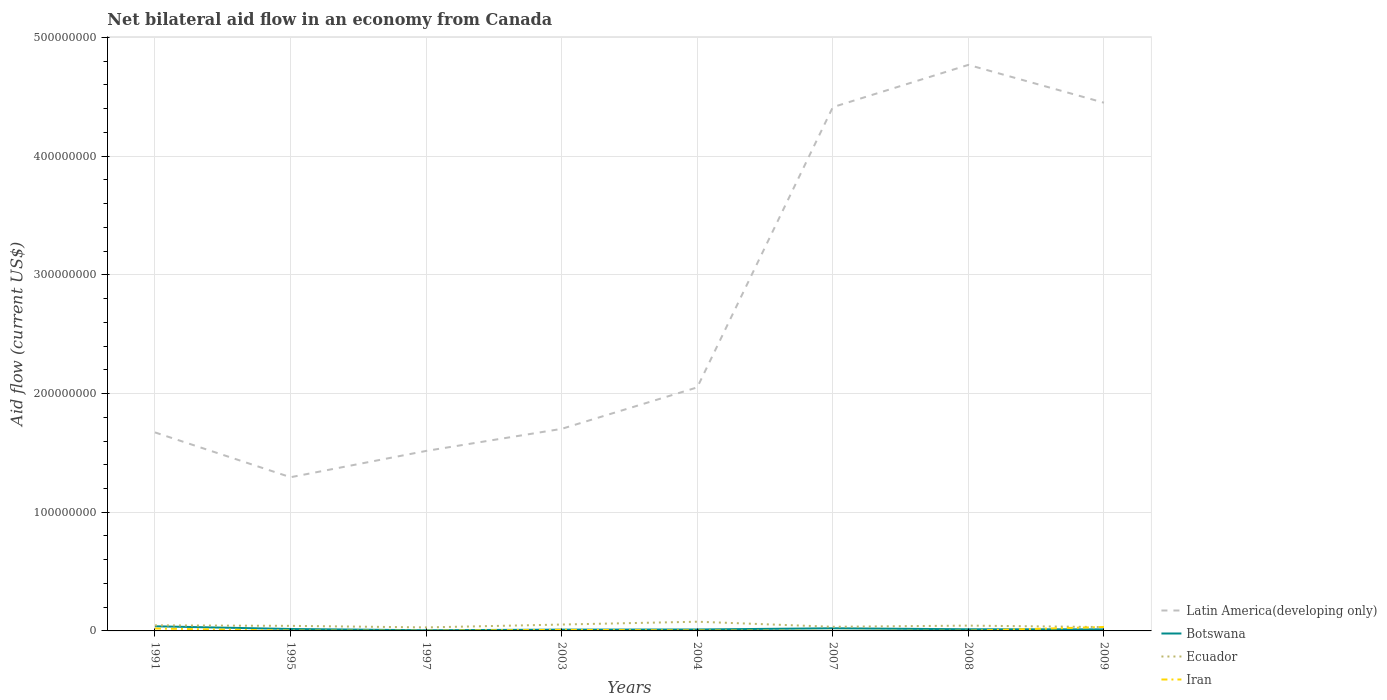Does the line corresponding to Ecuador intersect with the line corresponding to Iran?
Offer a terse response. Yes. Across all years, what is the maximum net bilateral aid flow in Botswana?
Provide a succinct answer. 5.70e+05. What is the total net bilateral aid flow in Botswana in the graph?
Give a very brief answer. 2.80e+06. What is the difference between the highest and the second highest net bilateral aid flow in Botswana?
Offer a very short reply. 3.32e+06. Is the net bilateral aid flow in Botswana strictly greater than the net bilateral aid flow in Latin America(developing only) over the years?
Your answer should be very brief. Yes. How many years are there in the graph?
Make the answer very short. 8. Are the values on the major ticks of Y-axis written in scientific E-notation?
Provide a succinct answer. No. Does the graph contain any zero values?
Offer a very short reply. No. What is the title of the graph?
Offer a very short reply. Net bilateral aid flow in an economy from Canada. What is the label or title of the X-axis?
Your answer should be compact. Years. What is the Aid flow (current US$) in Latin America(developing only) in 1991?
Give a very brief answer. 1.67e+08. What is the Aid flow (current US$) of Botswana in 1991?
Make the answer very short. 3.89e+06. What is the Aid flow (current US$) of Ecuador in 1991?
Your response must be concise. 4.69e+06. What is the Aid flow (current US$) in Iran in 1991?
Provide a succinct answer. 2.01e+06. What is the Aid flow (current US$) in Latin America(developing only) in 1995?
Provide a succinct answer. 1.29e+08. What is the Aid flow (current US$) in Botswana in 1995?
Your answer should be compact. 1.63e+06. What is the Aid flow (current US$) of Ecuador in 1995?
Offer a terse response. 4.27e+06. What is the Aid flow (current US$) of Latin America(developing only) in 1997?
Keep it short and to the point. 1.52e+08. What is the Aid flow (current US$) of Botswana in 1997?
Your response must be concise. 5.70e+05. What is the Aid flow (current US$) of Ecuador in 1997?
Give a very brief answer. 2.96e+06. What is the Aid flow (current US$) in Iran in 1997?
Your answer should be compact. 1.40e+05. What is the Aid flow (current US$) of Latin America(developing only) in 2003?
Offer a very short reply. 1.70e+08. What is the Aid flow (current US$) in Botswana in 2003?
Give a very brief answer. 1.09e+06. What is the Aid flow (current US$) of Ecuador in 2003?
Provide a succinct answer. 5.37e+06. What is the Aid flow (current US$) in Latin America(developing only) in 2004?
Your response must be concise. 2.05e+08. What is the Aid flow (current US$) in Botswana in 2004?
Offer a terse response. 1.21e+06. What is the Aid flow (current US$) of Ecuador in 2004?
Your answer should be compact. 7.76e+06. What is the Aid flow (current US$) of Iran in 2004?
Offer a very short reply. 4.30e+05. What is the Aid flow (current US$) of Latin America(developing only) in 2007?
Your response must be concise. 4.41e+08. What is the Aid flow (current US$) in Botswana in 2007?
Provide a short and direct response. 2.22e+06. What is the Aid flow (current US$) of Ecuador in 2007?
Make the answer very short. 3.49e+06. What is the Aid flow (current US$) of Iran in 2007?
Keep it short and to the point. 5.00e+04. What is the Aid flow (current US$) of Latin America(developing only) in 2008?
Offer a very short reply. 4.77e+08. What is the Aid flow (current US$) in Botswana in 2008?
Offer a terse response. 1.40e+06. What is the Aid flow (current US$) in Ecuador in 2008?
Give a very brief answer. 4.48e+06. What is the Aid flow (current US$) of Iran in 2008?
Offer a terse response. 1.90e+05. What is the Aid flow (current US$) of Latin America(developing only) in 2009?
Provide a short and direct response. 4.45e+08. What is the Aid flow (current US$) of Botswana in 2009?
Ensure brevity in your answer.  1.31e+06. What is the Aid flow (current US$) of Ecuador in 2009?
Give a very brief answer. 3.24e+06. What is the Aid flow (current US$) in Iran in 2009?
Keep it short and to the point. 3.31e+06. Across all years, what is the maximum Aid flow (current US$) in Latin America(developing only)?
Your response must be concise. 4.77e+08. Across all years, what is the maximum Aid flow (current US$) in Botswana?
Offer a terse response. 3.89e+06. Across all years, what is the maximum Aid flow (current US$) of Ecuador?
Your answer should be very brief. 7.76e+06. Across all years, what is the maximum Aid flow (current US$) of Iran?
Give a very brief answer. 3.31e+06. Across all years, what is the minimum Aid flow (current US$) of Latin America(developing only)?
Ensure brevity in your answer.  1.29e+08. Across all years, what is the minimum Aid flow (current US$) in Botswana?
Make the answer very short. 5.70e+05. Across all years, what is the minimum Aid flow (current US$) of Ecuador?
Offer a terse response. 2.96e+06. What is the total Aid flow (current US$) of Latin America(developing only) in the graph?
Your answer should be compact. 2.19e+09. What is the total Aid flow (current US$) of Botswana in the graph?
Provide a short and direct response. 1.33e+07. What is the total Aid flow (current US$) of Ecuador in the graph?
Ensure brevity in your answer.  3.63e+07. What is the total Aid flow (current US$) of Iran in the graph?
Make the answer very short. 7.32e+06. What is the difference between the Aid flow (current US$) in Latin America(developing only) in 1991 and that in 1995?
Provide a succinct answer. 3.78e+07. What is the difference between the Aid flow (current US$) in Botswana in 1991 and that in 1995?
Your answer should be compact. 2.26e+06. What is the difference between the Aid flow (current US$) in Ecuador in 1991 and that in 1995?
Keep it short and to the point. 4.20e+05. What is the difference between the Aid flow (current US$) of Iran in 1991 and that in 1995?
Ensure brevity in your answer.  1.72e+06. What is the difference between the Aid flow (current US$) in Latin America(developing only) in 1991 and that in 1997?
Make the answer very short. 1.56e+07. What is the difference between the Aid flow (current US$) in Botswana in 1991 and that in 1997?
Offer a very short reply. 3.32e+06. What is the difference between the Aid flow (current US$) in Ecuador in 1991 and that in 1997?
Make the answer very short. 1.73e+06. What is the difference between the Aid flow (current US$) of Iran in 1991 and that in 1997?
Your response must be concise. 1.87e+06. What is the difference between the Aid flow (current US$) in Latin America(developing only) in 1991 and that in 2003?
Offer a very short reply. -2.99e+06. What is the difference between the Aid flow (current US$) in Botswana in 1991 and that in 2003?
Your answer should be very brief. 2.80e+06. What is the difference between the Aid flow (current US$) of Ecuador in 1991 and that in 2003?
Offer a very short reply. -6.80e+05. What is the difference between the Aid flow (current US$) of Iran in 1991 and that in 2003?
Ensure brevity in your answer.  1.11e+06. What is the difference between the Aid flow (current US$) in Latin America(developing only) in 1991 and that in 2004?
Ensure brevity in your answer.  -3.79e+07. What is the difference between the Aid flow (current US$) of Botswana in 1991 and that in 2004?
Keep it short and to the point. 2.68e+06. What is the difference between the Aid flow (current US$) of Ecuador in 1991 and that in 2004?
Ensure brevity in your answer.  -3.07e+06. What is the difference between the Aid flow (current US$) of Iran in 1991 and that in 2004?
Provide a short and direct response. 1.58e+06. What is the difference between the Aid flow (current US$) of Latin America(developing only) in 1991 and that in 2007?
Give a very brief answer. -2.74e+08. What is the difference between the Aid flow (current US$) in Botswana in 1991 and that in 2007?
Provide a short and direct response. 1.67e+06. What is the difference between the Aid flow (current US$) of Ecuador in 1991 and that in 2007?
Give a very brief answer. 1.20e+06. What is the difference between the Aid flow (current US$) of Iran in 1991 and that in 2007?
Your answer should be very brief. 1.96e+06. What is the difference between the Aid flow (current US$) of Latin America(developing only) in 1991 and that in 2008?
Ensure brevity in your answer.  -3.10e+08. What is the difference between the Aid flow (current US$) of Botswana in 1991 and that in 2008?
Offer a terse response. 2.49e+06. What is the difference between the Aid flow (current US$) of Iran in 1991 and that in 2008?
Provide a succinct answer. 1.82e+06. What is the difference between the Aid flow (current US$) of Latin America(developing only) in 1991 and that in 2009?
Provide a short and direct response. -2.78e+08. What is the difference between the Aid flow (current US$) in Botswana in 1991 and that in 2009?
Keep it short and to the point. 2.58e+06. What is the difference between the Aid flow (current US$) of Ecuador in 1991 and that in 2009?
Provide a succinct answer. 1.45e+06. What is the difference between the Aid flow (current US$) of Iran in 1991 and that in 2009?
Your answer should be compact. -1.30e+06. What is the difference between the Aid flow (current US$) in Latin America(developing only) in 1995 and that in 1997?
Your answer should be compact. -2.22e+07. What is the difference between the Aid flow (current US$) in Botswana in 1995 and that in 1997?
Your answer should be compact. 1.06e+06. What is the difference between the Aid flow (current US$) of Ecuador in 1995 and that in 1997?
Provide a short and direct response. 1.31e+06. What is the difference between the Aid flow (current US$) in Iran in 1995 and that in 1997?
Provide a succinct answer. 1.50e+05. What is the difference between the Aid flow (current US$) of Latin America(developing only) in 1995 and that in 2003?
Your response must be concise. -4.08e+07. What is the difference between the Aid flow (current US$) in Botswana in 1995 and that in 2003?
Provide a short and direct response. 5.40e+05. What is the difference between the Aid flow (current US$) in Ecuador in 1995 and that in 2003?
Ensure brevity in your answer.  -1.10e+06. What is the difference between the Aid flow (current US$) in Iran in 1995 and that in 2003?
Make the answer very short. -6.10e+05. What is the difference between the Aid flow (current US$) of Latin America(developing only) in 1995 and that in 2004?
Give a very brief answer. -7.57e+07. What is the difference between the Aid flow (current US$) of Ecuador in 1995 and that in 2004?
Give a very brief answer. -3.49e+06. What is the difference between the Aid flow (current US$) of Latin America(developing only) in 1995 and that in 2007?
Your answer should be compact. -3.12e+08. What is the difference between the Aid flow (current US$) in Botswana in 1995 and that in 2007?
Provide a short and direct response. -5.90e+05. What is the difference between the Aid flow (current US$) in Ecuador in 1995 and that in 2007?
Your answer should be compact. 7.80e+05. What is the difference between the Aid flow (current US$) of Iran in 1995 and that in 2007?
Your answer should be very brief. 2.40e+05. What is the difference between the Aid flow (current US$) in Latin America(developing only) in 1995 and that in 2008?
Your answer should be compact. -3.47e+08. What is the difference between the Aid flow (current US$) in Botswana in 1995 and that in 2008?
Your answer should be compact. 2.30e+05. What is the difference between the Aid flow (current US$) in Ecuador in 1995 and that in 2008?
Keep it short and to the point. -2.10e+05. What is the difference between the Aid flow (current US$) of Iran in 1995 and that in 2008?
Provide a succinct answer. 1.00e+05. What is the difference between the Aid flow (current US$) of Latin America(developing only) in 1995 and that in 2009?
Provide a short and direct response. -3.16e+08. What is the difference between the Aid flow (current US$) in Botswana in 1995 and that in 2009?
Give a very brief answer. 3.20e+05. What is the difference between the Aid flow (current US$) in Ecuador in 1995 and that in 2009?
Make the answer very short. 1.03e+06. What is the difference between the Aid flow (current US$) of Iran in 1995 and that in 2009?
Make the answer very short. -3.02e+06. What is the difference between the Aid flow (current US$) of Latin America(developing only) in 1997 and that in 2003?
Your response must be concise. -1.86e+07. What is the difference between the Aid flow (current US$) of Botswana in 1997 and that in 2003?
Your answer should be very brief. -5.20e+05. What is the difference between the Aid flow (current US$) in Ecuador in 1997 and that in 2003?
Give a very brief answer. -2.41e+06. What is the difference between the Aid flow (current US$) in Iran in 1997 and that in 2003?
Give a very brief answer. -7.60e+05. What is the difference between the Aid flow (current US$) of Latin America(developing only) in 1997 and that in 2004?
Ensure brevity in your answer.  -5.35e+07. What is the difference between the Aid flow (current US$) in Botswana in 1997 and that in 2004?
Provide a succinct answer. -6.40e+05. What is the difference between the Aid flow (current US$) in Ecuador in 1997 and that in 2004?
Provide a short and direct response. -4.80e+06. What is the difference between the Aid flow (current US$) in Iran in 1997 and that in 2004?
Give a very brief answer. -2.90e+05. What is the difference between the Aid flow (current US$) of Latin America(developing only) in 1997 and that in 2007?
Give a very brief answer. -2.90e+08. What is the difference between the Aid flow (current US$) in Botswana in 1997 and that in 2007?
Offer a terse response. -1.65e+06. What is the difference between the Aid flow (current US$) in Ecuador in 1997 and that in 2007?
Make the answer very short. -5.30e+05. What is the difference between the Aid flow (current US$) of Latin America(developing only) in 1997 and that in 2008?
Keep it short and to the point. -3.25e+08. What is the difference between the Aid flow (current US$) of Botswana in 1997 and that in 2008?
Give a very brief answer. -8.30e+05. What is the difference between the Aid flow (current US$) of Ecuador in 1997 and that in 2008?
Provide a succinct answer. -1.52e+06. What is the difference between the Aid flow (current US$) in Latin America(developing only) in 1997 and that in 2009?
Your answer should be compact. -2.93e+08. What is the difference between the Aid flow (current US$) of Botswana in 1997 and that in 2009?
Keep it short and to the point. -7.40e+05. What is the difference between the Aid flow (current US$) in Ecuador in 1997 and that in 2009?
Keep it short and to the point. -2.80e+05. What is the difference between the Aid flow (current US$) of Iran in 1997 and that in 2009?
Make the answer very short. -3.17e+06. What is the difference between the Aid flow (current US$) in Latin America(developing only) in 2003 and that in 2004?
Ensure brevity in your answer.  -3.49e+07. What is the difference between the Aid flow (current US$) of Botswana in 2003 and that in 2004?
Give a very brief answer. -1.20e+05. What is the difference between the Aid flow (current US$) of Ecuador in 2003 and that in 2004?
Make the answer very short. -2.39e+06. What is the difference between the Aid flow (current US$) of Iran in 2003 and that in 2004?
Your response must be concise. 4.70e+05. What is the difference between the Aid flow (current US$) in Latin America(developing only) in 2003 and that in 2007?
Give a very brief answer. -2.71e+08. What is the difference between the Aid flow (current US$) of Botswana in 2003 and that in 2007?
Make the answer very short. -1.13e+06. What is the difference between the Aid flow (current US$) of Ecuador in 2003 and that in 2007?
Make the answer very short. 1.88e+06. What is the difference between the Aid flow (current US$) of Iran in 2003 and that in 2007?
Keep it short and to the point. 8.50e+05. What is the difference between the Aid flow (current US$) of Latin America(developing only) in 2003 and that in 2008?
Ensure brevity in your answer.  -3.07e+08. What is the difference between the Aid flow (current US$) of Botswana in 2003 and that in 2008?
Provide a succinct answer. -3.10e+05. What is the difference between the Aid flow (current US$) in Ecuador in 2003 and that in 2008?
Provide a short and direct response. 8.90e+05. What is the difference between the Aid flow (current US$) in Iran in 2003 and that in 2008?
Make the answer very short. 7.10e+05. What is the difference between the Aid flow (current US$) of Latin America(developing only) in 2003 and that in 2009?
Your response must be concise. -2.75e+08. What is the difference between the Aid flow (current US$) of Botswana in 2003 and that in 2009?
Provide a succinct answer. -2.20e+05. What is the difference between the Aid flow (current US$) in Ecuador in 2003 and that in 2009?
Your answer should be compact. 2.13e+06. What is the difference between the Aid flow (current US$) of Iran in 2003 and that in 2009?
Your answer should be very brief. -2.41e+06. What is the difference between the Aid flow (current US$) in Latin America(developing only) in 2004 and that in 2007?
Ensure brevity in your answer.  -2.36e+08. What is the difference between the Aid flow (current US$) of Botswana in 2004 and that in 2007?
Provide a succinct answer. -1.01e+06. What is the difference between the Aid flow (current US$) of Ecuador in 2004 and that in 2007?
Give a very brief answer. 4.27e+06. What is the difference between the Aid flow (current US$) in Latin America(developing only) in 2004 and that in 2008?
Your answer should be compact. -2.72e+08. What is the difference between the Aid flow (current US$) of Ecuador in 2004 and that in 2008?
Offer a terse response. 3.28e+06. What is the difference between the Aid flow (current US$) of Iran in 2004 and that in 2008?
Offer a very short reply. 2.40e+05. What is the difference between the Aid flow (current US$) in Latin America(developing only) in 2004 and that in 2009?
Your response must be concise. -2.40e+08. What is the difference between the Aid flow (current US$) of Ecuador in 2004 and that in 2009?
Your response must be concise. 4.52e+06. What is the difference between the Aid flow (current US$) in Iran in 2004 and that in 2009?
Your response must be concise. -2.88e+06. What is the difference between the Aid flow (current US$) of Latin America(developing only) in 2007 and that in 2008?
Make the answer very short. -3.56e+07. What is the difference between the Aid flow (current US$) in Botswana in 2007 and that in 2008?
Your response must be concise. 8.20e+05. What is the difference between the Aid flow (current US$) in Ecuador in 2007 and that in 2008?
Offer a very short reply. -9.90e+05. What is the difference between the Aid flow (current US$) of Iran in 2007 and that in 2008?
Give a very brief answer. -1.40e+05. What is the difference between the Aid flow (current US$) in Latin America(developing only) in 2007 and that in 2009?
Your response must be concise. -3.74e+06. What is the difference between the Aid flow (current US$) of Botswana in 2007 and that in 2009?
Keep it short and to the point. 9.10e+05. What is the difference between the Aid flow (current US$) of Ecuador in 2007 and that in 2009?
Offer a terse response. 2.50e+05. What is the difference between the Aid flow (current US$) in Iran in 2007 and that in 2009?
Your answer should be compact. -3.26e+06. What is the difference between the Aid flow (current US$) in Latin America(developing only) in 2008 and that in 2009?
Keep it short and to the point. 3.19e+07. What is the difference between the Aid flow (current US$) in Ecuador in 2008 and that in 2009?
Make the answer very short. 1.24e+06. What is the difference between the Aid flow (current US$) of Iran in 2008 and that in 2009?
Make the answer very short. -3.12e+06. What is the difference between the Aid flow (current US$) of Latin America(developing only) in 1991 and the Aid flow (current US$) of Botswana in 1995?
Keep it short and to the point. 1.66e+08. What is the difference between the Aid flow (current US$) in Latin America(developing only) in 1991 and the Aid flow (current US$) in Ecuador in 1995?
Offer a very short reply. 1.63e+08. What is the difference between the Aid flow (current US$) of Latin America(developing only) in 1991 and the Aid flow (current US$) of Iran in 1995?
Offer a terse response. 1.67e+08. What is the difference between the Aid flow (current US$) of Botswana in 1991 and the Aid flow (current US$) of Ecuador in 1995?
Your answer should be very brief. -3.80e+05. What is the difference between the Aid flow (current US$) of Botswana in 1991 and the Aid flow (current US$) of Iran in 1995?
Keep it short and to the point. 3.60e+06. What is the difference between the Aid flow (current US$) of Ecuador in 1991 and the Aid flow (current US$) of Iran in 1995?
Your response must be concise. 4.40e+06. What is the difference between the Aid flow (current US$) in Latin America(developing only) in 1991 and the Aid flow (current US$) in Botswana in 1997?
Give a very brief answer. 1.67e+08. What is the difference between the Aid flow (current US$) of Latin America(developing only) in 1991 and the Aid flow (current US$) of Ecuador in 1997?
Make the answer very short. 1.64e+08. What is the difference between the Aid flow (current US$) of Latin America(developing only) in 1991 and the Aid flow (current US$) of Iran in 1997?
Ensure brevity in your answer.  1.67e+08. What is the difference between the Aid flow (current US$) of Botswana in 1991 and the Aid flow (current US$) of Ecuador in 1997?
Your answer should be compact. 9.30e+05. What is the difference between the Aid flow (current US$) in Botswana in 1991 and the Aid flow (current US$) in Iran in 1997?
Keep it short and to the point. 3.75e+06. What is the difference between the Aid flow (current US$) in Ecuador in 1991 and the Aid flow (current US$) in Iran in 1997?
Offer a terse response. 4.55e+06. What is the difference between the Aid flow (current US$) of Latin America(developing only) in 1991 and the Aid flow (current US$) of Botswana in 2003?
Keep it short and to the point. 1.66e+08. What is the difference between the Aid flow (current US$) of Latin America(developing only) in 1991 and the Aid flow (current US$) of Ecuador in 2003?
Keep it short and to the point. 1.62e+08. What is the difference between the Aid flow (current US$) in Latin America(developing only) in 1991 and the Aid flow (current US$) in Iran in 2003?
Ensure brevity in your answer.  1.66e+08. What is the difference between the Aid flow (current US$) of Botswana in 1991 and the Aid flow (current US$) of Ecuador in 2003?
Provide a succinct answer. -1.48e+06. What is the difference between the Aid flow (current US$) of Botswana in 1991 and the Aid flow (current US$) of Iran in 2003?
Provide a short and direct response. 2.99e+06. What is the difference between the Aid flow (current US$) of Ecuador in 1991 and the Aid flow (current US$) of Iran in 2003?
Ensure brevity in your answer.  3.79e+06. What is the difference between the Aid flow (current US$) in Latin America(developing only) in 1991 and the Aid flow (current US$) in Botswana in 2004?
Your response must be concise. 1.66e+08. What is the difference between the Aid flow (current US$) in Latin America(developing only) in 1991 and the Aid flow (current US$) in Ecuador in 2004?
Provide a short and direct response. 1.59e+08. What is the difference between the Aid flow (current US$) in Latin America(developing only) in 1991 and the Aid flow (current US$) in Iran in 2004?
Your answer should be very brief. 1.67e+08. What is the difference between the Aid flow (current US$) of Botswana in 1991 and the Aid flow (current US$) of Ecuador in 2004?
Provide a succinct answer. -3.87e+06. What is the difference between the Aid flow (current US$) of Botswana in 1991 and the Aid flow (current US$) of Iran in 2004?
Your response must be concise. 3.46e+06. What is the difference between the Aid flow (current US$) of Ecuador in 1991 and the Aid flow (current US$) of Iran in 2004?
Your answer should be very brief. 4.26e+06. What is the difference between the Aid flow (current US$) in Latin America(developing only) in 1991 and the Aid flow (current US$) in Botswana in 2007?
Your answer should be very brief. 1.65e+08. What is the difference between the Aid flow (current US$) of Latin America(developing only) in 1991 and the Aid flow (current US$) of Ecuador in 2007?
Make the answer very short. 1.64e+08. What is the difference between the Aid flow (current US$) in Latin America(developing only) in 1991 and the Aid flow (current US$) in Iran in 2007?
Give a very brief answer. 1.67e+08. What is the difference between the Aid flow (current US$) of Botswana in 1991 and the Aid flow (current US$) of Iran in 2007?
Offer a terse response. 3.84e+06. What is the difference between the Aid flow (current US$) in Ecuador in 1991 and the Aid flow (current US$) in Iran in 2007?
Provide a succinct answer. 4.64e+06. What is the difference between the Aid flow (current US$) in Latin America(developing only) in 1991 and the Aid flow (current US$) in Botswana in 2008?
Provide a short and direct response. 1.66e+08. What is the difference between the Aid flow (current US$) in Latin America(developing only) in 1991 and the Aid flow (current US$) in Ecuador in 2008?
Keep it short and to the point. 1.63e+08. What is the difference between the Aid flow (current US$) of Latin America(developing only) in 1991 and the Aid flow (current US$) of Iran in 2008?
Provide a short and direct response. 1.67e+08. What is the difference between the Aid flow (current US$) in Botswana in 1991 and the Aid flow (current US$) in Ecuador in 2008?
Your answer should be very brief. -5.90e+05. What is the difference between the Aid flow (current US$) of Botswana in 1991 and the Aid flow (current US$) of Iran in 2008?
Keep it short and to the point. 3.70e+06. What is the difference between the Aid flow (current US$) in Ecuador in 1991 and the Aid flow (current US$) in Iran in 2008?
Your answer should be very brief. 4.50e+06. What is the difference between the Aid flow (current US$) in Latin America(developing only) in 1991 and the Aid flow (current US$) in Botswana in 2009?
Provide a short and direct response. 1.66e+08. What is the difference between the Aid flow (current US$) of Latin America(developing only) in 1991 and the Aid flow (current US$) of Ecuador in 2009?
Make the answer very short. 1.64e+08. What is the difference between the Aid flow (current US$) of Latin America(developing only) in 1991 and the Aid flow (current US$) of Iran in 2009?
Keep it short and to the point. 1.64e+08. What is the difference between the Aid flow (current US$) in Botswana in 1991 and the Aid flow (current US$) in Ecuador in 2009?
Provide a succinct answer. 6.50e+05. What is the difference between the Aid flow (current US$) of Botswana in 1991 and the Aid flow (current US$) of Iran in 2009?
Keep it short and to the point. 5.80e+05. What is the difference between the Aid flow (current US$) in Ecuador in 1991 and the Aid flow (current US$) in Iran in 2009?
Give a very brief answer. 1.38e+06. What is the difference between the Aid flow (current US$) in Latin America(developing only) in 1995 and the Aid flow (current US$) in Botswana in 1997?
Provide a succinct answer. 1.29e+08. What is the difference between the Aid flow (current US$) of Latin America(developing only) in 1995 and the Aid flow (current US$) of Ecuador in 1997?
Provide a short and direct response. 1.27e+08. What is the difference between the Aid flow (current US$) of Latin America(developing only) in 1995 and the Aid flow (current US$) of Iran in 1997?
Ensure brevity in your answer.  1.29e+08. What is the difference between the Aid flow (current US$) in Botswana in 1995 and the Aid flow (current US$) in Ecuador in 1997?
Give a very brief answer. -1.33e+06. What is the difference between the Aid flow (current US$) of Botswana in 1995 and the Aid flow (current US$) of Iran in 1997?
Your response must be concise. 1.49e+06. What is the difference between the Aid flow (current US$) in Ecuador in 1995 and the Aid flow (current US$) in Iran in 1997?
Your answer should be compact. 4.13e+06. What is the difference between the Aid flow (current US$) in Latin America(developing only) in 1995 and the Aid flow (current US$) in Botswana in 2003?
Provide a short and direct response. 1.28e+08. What is the difference between the Aid flow (current US$) in Latin America(developing only) in 1995 and the Aid flow (current US$) in Ecuador in 2003?
Your answer should be compact. 1.24e+08. What is the difference between the Aid flow (current US$) in Latin America(developing only) in 1995 and the Aid flow (current US$) in Iran in 2003?
Your response must be concise. 1.29e+08. What is the difference between the Aid flow (current US$) of Botswana in 1995 and the Aid flow (current US$) of Ecuador in 2003?
Make the answer very short. -3.74e+06. What is the difference between the Aid flow (current US$) of Botswana in 1995 and the Aid flow (current US$) of Iran in 2003?
Make the answer very short. 7.30e+05. What is the difference between the Aid flow (current US$) in Ecuador in 1995 and the Aid flow (current US$) in Iran in 2003?
Your answer should be compact. 3.37e+06. What is the difference between the Aid flow (current US$) of Latin America(developing only) in 1995 and the Aid flow (current US$) of Botswana in 2004?
Offer a terse response. 1.28e+08. What is the difference between the Aid flow (current US$) in Latin America(developing only) in 1995 and the Aid flow (current US$) in Ecuador in 2004?
Your answer should be compact. 1.22e+08. What is the difference between the Aid flow (current US$) of Latin America(developing only) in 1995 and the Aid flow (current US$) of Iran in 2004?
Provide a succinct answer. 1.29e+08. What is the difference between the Aid flow (current US$) of Botswana in 1995 and the Aid flow (current US$) of Ecuador in 2004?
Your answer should be compact. -6.13e+06. What is the difference between the Aid flow (current US$) of Botswana in 1995 and the Aid flow (current US$) of Iran in 2004?
Your answer should be compact. 1.20e+06. What is the difference between the Aid flow (current US$) of Ecuador in 1995 and the Aid flow (current US$) of Iran in 2004?
Your answer should be very brief. 3.84e+06. What is the difference between the Aid flow (current US$) of Latin America(developing only) in 1995 and the Aid flow (current US$) of Botswana in 2007?
Give a very brief answer. 1.27e+08. What is the difference between the Aid flow (current US$) in Latin America(developing only) in 1995 and the Aid flow (current US$) in Ecuador in 2007?
Provide a short and direct response. 1.26e+08. What is the difference between the Aid flow (current US$) in Latin America(developing only) in 1995 and the Aid flow (current US$) in Iran in 2007?
Your response must be concise. 1.29e+08. What is the difference between the Aid flow (current US$) in Botswana in 1995 and the Aid flow (current US$) in Ecuador in 2007?
Provide a succinct answer. -1.86e+06. What is the difference between the Aid flow (current US$) of Botswana in 1995 and the Aid flow (current US$) of Iran in 2007?
Your answer should be compact. 1.58e+06. What is the difference between the Aid flow (current US$) in Ecuador in 1995 and the Aid flow (current US$) in Iran in 2007?
Offer a terse response. 4.22e+06. What is the difference between the Aid flow (current US$) of Latin America(developing only) in 1995 and the Aid flow (current US$) of Botswana in 2008?
Your answer should be compact. 1.28e+08. What is the difference between the Aid flow (current US$) of Latin America(developing only) in 1995 and the Aid flow (current US$) of Ecuador in 2008?
Your answer should be compact. 1.25e+08. What is the difference between the Aid flow (current US$) in Latin America(developing only) in 1995 and the Aid flow (current US$) in Iran in 2008?
Give a very brief answer. 1.29e+08. What is the difference between the Aid flow (current US$) of Botswana in 1995 and the Aid flow (current US$) of Ecuador in 2008?
Offer a very short reply. -2.85e+06. What is the difference between the Aid flow (current US$) of Botswana in 1995 and the Aid flow (current US$) of Iran in 2008?
Your response must be concise. 1.44e+06. What is the difference between the Aid flow (current US$) in Ecuador in 1995 and the Aid flow (current US$) in Iran in 2008?
Provide a succinct answer. 4.08e+06. What is the difference between the Aid flow (current US$) in Latin America(developing only) in 1995 and the Aid flow (current US$) in Botswana in 2009?
Offer a very short reply. 1.28e+08. What is the difference between the Aid flow (current US$) of Latin America(developing only) in 1995 and the Aid flow (current US$) of Ecuador in 2009?
Ensure brevity in your answer.  1.26e+08. What is the difference between the Aid flow (current US$) of Latin America(developing only) in 1995 and the Aid flow (current US$) of Iran in 2009?
Your answer should be very brief. 1.26e+08. What is the difference between the Aid flow (current US$) in Botswana in 1995 and the Aid flow (current US$) in Ecuador in 2009?
Give a very brief answer. -1.61e+06. What is the difference between the Aid flow (current US$) in Botswana in 1995 and the Aid flow (current US$) in Iran in 2009?
Provide a short and direct response. -1.68e+06. What is the difference between the Aid flow (current US$) in Ecuador in 1995 and the Aid flow (current US$) in Iran in 2009?
Your answer should be compact. 9.60e+05. What is the difference between the Aid flow (current US$) of Latin America(developing only) in 1997 and the Aid flow (current US$) of Botswana in 2003?
Offer a terse response. 1.51e+08. What is the difference between the Aid flow (current US$) in Latin America(developing only) in 1997 and the Aid flow (current US$) in Ecuador in 2003?
Provide a short and direct response. 1.46e+08. What is the difference between the Aid flow (current US$) of Latin America(developing only) in 1997 and the Aid flow (current US$) of Iran in 2003?
Offer a very short reply. 1.51e+08. What is the difference between the Aid flow (current US$) of Botswana in 1997 and the Aid flow (current US$) of Ecuador in 2003?
Give a very brief answer. -4.80e+06. What is the difference between the Aid flow (current US$) in Botswana in 1997 and the Aid flow (current US$) in Iran in 2003?
Provide a succinct answer. -3.30e+05. What is the difference between the Aid flow (current US$) in Ecuador in 1997 and the Aid flow (current US$) in Iran in 2003?
Provide a succinct answer. 2.06e+06. What is the difference between the Aid flow (current US$) in Latin America(developing only) in 1997 and the Aid flow (current US$) in Botswana in 2004?
Provide a short and direct response. 1.50e+08. What is the difference between the Aid flow (current US$) in Latin America(developing only) in 1997 and the Aid flow (current US$) in Ecuador in 2004?
Keep it short and to the point. 1.44e+08. What is the difference between the Aid flow (current US$) of Latin America(developing only) in 1997 and the Aid flow (current US$) of Iran in 2004?
Provide a short and direct response. 1.51e+08. What is the difference between the Aid flow (current US$) of Botswana in 1997 and the Aid flow (current US$) of Ecuador in 2004?
Provide a succinct answer. -7.19e+06. What is the difference between the Aid flow (current US$) in Ecuador in 1997 and the Aid flow (current US$) in Iran in 2004?
Your answer should be compact. 2.53e+06. What is the difference between the Aid flow (current US$) of Latin America(developing only) in 1997 and the Aid flow (current US$) of Botswana in 2007?
Your answer should be very brief. 1.49e+08. What is the difference between the Aid flow (current US$) in Latin America(developing only) in 1997 and the Aid flow (current US$) in Ecuador in 2007?
Your response must be concise. 1.48e+08. What is the difference between the Aid flow (current US$) in Latin America(developing only) in 1997 and the Aid flow (current US$) in Iran in 2007?
Your answer should be compact. 1.52e+08. What is the difference between the Aid flow (current US$) of Botswana in 1997 and the Aid flow (current US$) of Ecuador in 2007?
Provide a short and direct response. -2.92e+06. What is the difference between the Aid flow (current US$) in Botswana in 1997 and the Aid flow (current US$) in Iran in 2007?
Provide a short and direct response. 5.20e+05. What is the difference between the Aid flow (current US$) of Ecuador in 1997 and the Aid flow (current US$) of Iran in 2007?
Provide a short and direct response. 2.91e+06. What is the difference between the Aid flow (current US$) of Latin America(developing only) in 1997 and the Aid flow (current US$) of Botswana in 2008?
Offer a very short reply. 1.50e+08. What is the difference between the Aid flow (current US$) in Latin America(developing only) in 1997 and the Aid flow (current US$) in Ecuador in 2008?
Your answer should be compact. 1.47e+08. What is the difference between the Aid flow (current US$) in Latin America(developing only) in 1997 and the Aid flow (current US$) in Iran in 2008?
Keep it short and to the point. 1.51e+08. What is the difference between the Aid flow (current US$) in Botswana in 1997 and the Aid flow (current US$) in Ecuador in 2008?
Your answer should be compact. -3.91e+06. What is the difference between the Aid flow (current US$) in Ecuador in 1997 and the Aid flow (current US$) in Iran in 2008?
Your response must be concise. 2.77e+06. What is the difference between the Aid flow (current US$) of Latin America(developing only) in 1997 and the Aid flow (current US$) of Botswana in 2009?
Provide a short and direct response. 1.50e+08. What is the difference between the Aid flow (current US$) of Latin America(developing only) in 1997 and the Aid flow (current US$) of Ecuador in 2009?
Offer a terse response. 1.48e+08. What is the difference between the Aid flow (current US$) of Latin America(developing only) in 1997 and the Aid flow (current US$) of Iran in 2009?
Provide a short and direct response. 1.48e+08. What is the difference between the Aid flow (current US$) of Botswana in 1997 and the Aid flow (current US$) of Ecuador in 2009?
Give a very brief answer. -2.67e+06. What is the difference between the Aid flow (current US$) in Botswana in 1997 and the Aid flow (current US$) in Iran in 2009?
Give a very brief answer. -2.74e+06. What is the difference between the Aid flow (current US$) of Ecuador in 1997 and the Aid flow (current US$) of Iran in 2009?
Keep it short and to the point. -3.50e+05. What is the difference between the Aid flow (current US$) in Latin America(developing only) in 2003 and the Aid flow (current US$) in Botswana in 2004?
Offer a terse response. 1.69e+08. What is the difference between the Aid flow (current US$) of Latin America(developing only) in 2003 and the Aid flow (current US$) of Ecuador in 2004?
Keep it short and to the point. 1.62e+08. What is the difference between the Aid flow (current US$) of Latin America(developing only) in 2003 and the Aid flow (current US$) of Iran in 2004?
Ensure brevity in your answer.  1.70e+08. What is the difference between the Aid flow (current US$) of Botswana in 2003 and the Aid flow (current US$) of Ecuador in 2004?
Make the answer very short. -6.67e+06. What is the difference between the Aid flow (current US$) in Botswana in 2003 and the Aid flow (current US$) in Iran in 2004?
Offer a very short reply. 6.60e+05. What is the difference between the Aid flow (current US$) of Ecuador in 2003 and the Aid flow (current US$) of Iran in 2004?
Ensure brevity in your answer.  4.94e+06. What is the difference between the Aid flow (current US$) of Latin America(developing only) in 2003 and the Aid flow (current US$) of Botswana in 2007?
Your answer should be compact. 1.68e+08. What is the difference between the Aid flow (current US$) of Latin America(developing only) in 2003 and the Aid flow (current US$) of Ecuador in 2007?
Keep it short and to the point. 1.67e+08. What is the difference between the Aid flow (current US$) of Latin America(developing only) in 2003 and the Aid flow (current US$) of Iran in 2007?
Your answer should be compact. 1.70e+08. What is the difference between the Aid flow (current US$) in Botswana in 2003 and the Aid flow (current US$) in Ecuador in 2007?
Offer a very short reply. -2.40e+06. What is the difference between the Aid flow (current US$) in Botswana in 2003 and the Aid flow (current US$) in Iran in 2007?
Ensure brevity in your answer.  1.04e+06. What is the difference between the Aid flow (current US$) in Ecuador in 2003 and the Aid flow (current US$) in Iran in 2007?
Your answer should be compact. 5.32e+06. What is the difference between the Aid flow (current US$) in Latin America(developing only) in 2003 and the Aid flow (current US$) in Botswana in 2008?
Your response must be concise. 1.69e+08. What is the difference between the Aid flow (current US$) of Latin America(developing only) in 2003 and the Aid flow (current US$) of Ecuador in 2008?
Ensure brevity in your answer.  1.66e+08. What is the difference between the Aid flow (current US$) in Latin America(developing only) in 2003 and the Aid flow (current US$) in Iran in 2008?
Make the answer very short. 1.70e+08. What is the difference between the Aid flow (current US$) of Botswana in 2003 and the Aid flow (current US$) of Ecuador in 2008?
Offer a very short reply. -3.39e+06. What is the difference between the Aid flow (current US$) of Botswana in 2003 and the Aid flow (current US$) of Iran in 2008?
Keep it short and to the point. 9.00e+05. What is the difference between the Aid flow (current US$) in Ecuador in 2003 and the Aid flow (current US$) in Iran in 2008?
Keep it short and to the point. 5.18e+06. What is the difference between the Aid flow (current US$) in Latin America(developing only) in 2003 and the Aid flow (current US$) in Botswana in 2009?
Provide a short and direct response. 1.69e+08. What is the difference between the Aid flow (current US$) in Latin America(developing only) in 2003 and the Aid flow (current US$) in Ecuador in 2009?
Your response must be concise. 1.67e+08. What is the difference between the Aid flow (current US$) in Latin America(developing only) in 2003 and the Aid flow (current US$) in Iran in 2009?
Offer a very short reply. 1.67e+08. What is the difference between the Aid flow (current US$) of Botswana in 2003 and the Aid flow (current US$) of Ecuador in 2009?
Provide a short and direct response. -2.15e+06. What is the difference between the Aid flow (current US$) in Botswana in 2003 and the Aid flow (current US$) in Iran in 2009?
Give a very brief answer. -2.22e+06. What is the difference between the Aid flow (current US$) in Ecuador in 2003 and the Aid flow (current US$) in Iran in 2009?
Your answer should be compact. 2.06e+06. What is the difference between the Aid flow (current US$) in Latin America(developing only) in 2004 and the Aid flow (current US$) in Botswana in 2007?
Your answer should be compact. 2.03e+08. What is the difference between the Aid flow (current US$) of Latin America(developing only) in 2004 and the Aid flow (current US$) of Ecuador in 2007?
Offer a terse response. 2.02e+08. What is the difference between the Aid flow (current US$) in Latin America(developing only) in 2004 and the Aid flow (current US$) in Iran in 2007?
Offer a terse response. 2.05e+08. What is the difference between the Aid flow (current US$) of Botswana in 2004 and the Aid flow (current US$) of Ecuador in 2007?
Offer a terse response. -2.28e+06. What is the difference between the Aid flow (current US$) in Botswana in 2004 and the Aid flow (current US$) in Iran in 2007?
Offer a terse response. 1.16e+06. What is the difference between the Aid flow (current US$) of Ecuador in 2004 and the Aid flow (current US$) of Iran in 2007?
Keep it short and to the point. 7.71e+06. What is the difference between the Aid flow (current US$) in Latin America(developing only) in 2004 and the Aid flow (current US$) in Botswana in 2008?
Ensure brevity in your answer.  2.04e+08. What is the difference between the Aid flow (current US$) of Latin America(developing only) in 2004 and the Aid flow (current US$) of Ecuador in 2008?
Keep it short and to the point. 2.01e+08. What is the difference between the Aid flow (current US$) of Latin America(developing only) in 2004 and the Aid flow (current US$) of Iran in 2008?
Keep it short and to the point. 2.05e+08. What is the difference between the Aid flow (current US$) in Botswana in 2004 and the Aid flow (current US$) in Ecuador in 2008?
Your response must be concise. -3.27e+06. What is the difference between the Aid flow (current US$) of Botswana in 2004 and the Aid flow (current US$) of Iran in 2008?
Your answer should be very brief. 1.02e+06. What is the difference between the Aid flow (current US$) of Ecuador in 2004 and the Aid flow (current US$) of Iran in 2008?
Ensure brevity in your answer.  7.57e+06. What is the difference between the Aid flow (current US$) in Latin America(developing only) in 2004 and the Aid flow (current US$) in Botswana in 2009?
Your response must be concise. 2.04e+08. What is the difference between the Aid flow (current US$) of Latin America(developing only) in 2004 and the Aid flow (current US$) of Ecuador in 2009?
Keep it short and to the point. 2.02e+08. What is the difference between the Aid flow (current US$) in Latin America(developing only) in 2004 and the Aid flow (current US$) in Iran in 2009?
Provide a succinct answer. 2.02e+08. What is the difference between the Aid flow (current US$) in Botswana in 2004 and the Aid flow (current US$) in Ecuador in 2009?
Make the answer very short. -2.03e+06. What is the difference between the Aid flow (current US$) in Botswana in 2004 and the Aid flow (current US$) in Iran in 2009?
Keep it short and to the point. -2.10e+06. What is the difference between the Aid flow (current US$) of Ecuador in 2004 and the Aid flow (current US$) of Iran in 2009?
Offer a terse response. 4.45e+06. What is the difference between the Aid flow (current US$) in Latin America(developing only) in 2007 and the Aid flow (current US$) in Botswana in 2008?
Offer a terse response. 4.40e+08. What is the difference between the Aid flow (current US$) of Latin America(developing only) in 2007 and the Aid flow (current US$) of Ecuador in 2008?
Your response must be concise. 4.37e+08. What is the difference between the Aid flow (current US$) in Latin America(developing only) in 2007 and the Aid flow (current US$) in Iran in 2008?
Provide a succinct answer. 4.41e+08. What is the difference between the Aid flow (current US$) in Botswana in 2007 and the Aid flow (current US$) in Ecuador in 2008?
Keep it short and to the point. -2.26e+06. What is the difference between the Aid flow (current US$) of Botswana in 2007 and the Aid flow (current US$) of Iran in 2008?
Ensure brevity in your answer.  2.03e+06. What is the difference between the Aid flow (current US$) of Ecuador in 2007 and the Aid flow (current US$) of Iran in 2008?
Keep it short and to the point. 3.30e+06. What is the difference between the Aid flow (current US$) of Latin America(developing only) in 2007 and the Aid flow (current US$) of Botswana in 2009?
Offer a terse response. 4.40e+08. What is the difference between the Aid flow (current US$) of Latin America(developing only) in 2007 and the Aid flow (current US$) of Ecuador in 2009?
Provide a short and direct response. 4.38e+08. What is the difference between the Aid flow (current US$) in Latin America(developing only) in 2007 and the Aid flow (current US$) in Iran in 2009?
Ensure brevity in your answer.  4.38e+08. What is the difference between the Aid flow (current US$) in Botswana in 2007 and the Aid flow (current US$) in Ecuador in 2009?
Offer a terse response. -1.02e+06. What is the difference between the Aid flow (current US$) in Botswana in 2007 and the Aid flow (current US$) in Iran in 2009?
Make the answer very short. -1.09e+06. What is the difference between the Aid flow (current US$) of Latin America(developing only) in 2008 and the Aid flow (current US$) of Botswana in 2009?
Give a very brief answer. 4.76e+08. What is the difference between the Aid flow (current US$) of Latin America(developing only) in 2008 and the Aid flow (current US$) of Ecuador in 2009?
Keep it short and to the point. 4.74e+08. What is the difference between the Aid flow (current US$) in Latin America(developing only) in 2008 and the Aid flow (current US$) in Iran in 2009?
Give a very brief answer. 4.74e+08. What is the difference between the Aid flow (current US$) in Botswana in 2008 and the Aid flow (current US$) in Ecuador in 2009?
Your response must be concise. -1.84e+06. What is the difference between the Aid flow (current US$) in Botswana in 2008 and the Aid flow (current US$) in Iran in 2009?
Your answer should be compact. -1.91e+06. What is the difference between the Aid flow (current US$) of Ecuador in 2008 and the Aid flow (current US$) of Iran in 2009?
Offer a very short reply. 1.17e+06. What is the average Aid flow (current US$) of Latin America(developing only) per year?
Make the answer very short. 2.73e+08. What is the average Aid flow (current US$) of Botswana per year?
Keep it short and to the point. 1.66e+06. What is the average Aid flow (current US$) in Ecuador per year?
Keep it short and to the point. 4.53e+06. What is the average Aid flow (current US$) of Iran per year?
Provide a succinct answer. 9.15e+05. In the year 1991, what is the difference between the Aid flow (current US$) of Latin America(developing only) and Aid flow (current US$) of Botswana?
Provide a succinct answer. 1.63e+08. In the year 1991, what is the difference between the Aid flow (current US$) of Latin America(developing only) and Aid flow (current US$) of Ecuador?
Give a very brief answer. 1.63e+08. In the year 1991, what is the difference between the Aid flow (current US$) of Latin America(developing only) and Aid flow (current US$) of Iran?
Offer a terse response. 1.65e+08. In the year 1991, what is the difference between the Aid flow (current US$) of Botswana and Aid flow (current US$) of Ecuador?
Provide a succinct answer. -8.00e+05. In the year 1991, what is the difference between the Aid flow (current US$) of Botswana and Aid flow (current US$) of Iran?
Offer a terse response. 1.88e+06. In the year 1991, what is the difference between the Aid flow (current US$) in Ecuador and Aid flow (current US$) in Iran?
Your answer should be compact. 2.68e+06. In the year 1995, what is the difference between the Aid flow (current US$) in Latin America(developing only) and Aid flow (current US$) in Botswana?
Your answer should be compact. 1.28e+08. In the year 1995, what is the difference between the Aid flow (current US$) of Latin America(developing only) and Aid flow (current US$) of Ecuador?
Keep it short and to the point. 1.25e+08. In the year 1995, what is the difference between the Aid flow (current US$) in Latin America(developing only) and Aid flow (current US$) in Iran?
Offer a very short reply. 1.29e+08. In the year 1995, what is the difference between the Aid flow (current US$) of Botswana and Aid flow (current US$) of Ecuador?
Keep it short and to the point. -2.64e+06. In the year 1995, what is the difference between the Aid flow (current US$) of Botswana and Aid flow (current US$) of Iran?
Your answer should be compact. 1.34e+06. In the year 1995, what is the difference between the Aid flow (current US$) in Ecuador and Aid flow (current US$) in Iran?
Your answer should be very brief. 3.98e+06. In the year 1997, what is the difference between the Aid flow (current US$) in Latin America(developing only) and Aid flow (current US$) in Botswana?
Keep it short and to the point. 1.51e+08. In the year 1997, what is the difference between the Aid flow (current US$) of Latin America(developing only) and Aid flow (current US$) of Ecuador?
Offer a terse response. 1.49e+08. In the year 1997, what is the difference between the Aid flow (current US$) of Latin America(developing only) and Aid flow (current US$) of Iran?
Give a very brief answer. 1.51e+08. In the year 1997, what is the difference between the Aid flow (current US$) of Botswana and Aid flow (current US$) of Ecuador?
Provide a short and direct response. -2.39e+06. In the year 1997, what is the difference between the Aid flow (current US$) of Botswana and Aid flow (current US$) of Iran?
Provide a succinct answer. 4.30e+05. In the year 1997, what is the difference between the Aid flow (current US$) of Ecuador and Aid flow (current US$) of Iran?
Offer a very short reply. 2.82e+06. In the year 2003, what is the difference between the Aid flow (current US$) of Latin America(developing only) and Aid flow (current US$) of Botswana?
Provide a short and direct response. 1.69e+08. In the year 2003, what is the difference between the Aid flow (current US$) in Latin America(developing only) and Aid flow (current US$) in Ecuador?
Provide a succinct answer. 1.65e+08. In the year 2003, what is the difference between the Aid flow (current US$) in Latin America(developing only) and Aid flow (current US$) in Iran?
Your response must be concise. 1.69e+08. In the year 2003, what is the difference between the Aid flow (current US$) of Botswana and Aid flow (current US$) of Ecuador?
Your answer should be compact. -4.28e+06. In the year 2003, what is the difference between the Aid flow (current US$) in Botswana and Aid flow (current US$) in Iran?
Make the answer very short. 1.90e+05. In the year 2003, what is the difference between the Aid flow (current US$) in Ecuador and Aid flow (current US$) in Iran?
Keep it short and to the point. 4.47e+06. In the year 2004, what is the difference between the Aid flow (current US$) in Latin America(developing only) and Aid flow (current US$) in Botswana?
Make the answer very short. 2.04e+08. In the year 2004, what is the difference between the Aid flow (current US$) in Latin America(developing only) and Aid flow (current US$) in Ecuador?
Keep it short and to the point. 1.97e+08. In the year 2004, what is the difference between the Aid flow (current US$) of Latin America(developing only) and Aid flow (current US$) of Iran?
Provide a short and direct response. 2.05e+08. In the year 2004, what is the difference between the Aid flow (current US$) of Botswana and Aid flow (current US$) of Ecuador?
Your answer should be compact. -6.55e+06. In the year 2004, what is the difference between the Aid flow (current US$) in Botswana and Aid flow (current US$) in Iran?
Your answer should be very brief. 7.80e+05. In the year 2004, what is the difference between the Aid flow (current US$) of Ecuador and Aid flow (current US$) of Iran?
Ensure brevity in your answer.  7.33e+06. In the year 2007, what is the difference between the Aid flow (current US$) of Latin America(developing only) and Aid flow (current US$) of Botswana?
Your answer should be very brief. 4.39e+08. In the year 2007, what is the difference between the Aid flow (current US$) of Latin America(developing only) and Aid flow (current US$) of Ecuador?
Offer a terse response. 4.38e+08. In the year 2007, what is the difference between the Aid flow (current US$) in Latin America(developing only) and Aid flow (current US$) in Iran?
Keep it short and to the point. 4.41e+08. In the year 2007, what is the difference between the Aid flow (current US$) in Botswana and Aid flow (current US$) in Ecuador?
Ensure brevity in your answer.  -1.27e+06. In the year 2007, what is the difference between the Aid flow (current US$) of Botswana and Aid flow (current US$) of Iran?
Your answer should be compact. 2.17e+06. In the year 2007, what is the difference between the Aid flow (current US$) of Ecuador and Aid flow (current US$) of Iran?
Ensure brevity in your answer.  3.44e+06. In the year 2008, what is the difference between the Aid flow (current US$) in Latin America(developing only) and Aid flow (current US$) in Botswana?
Offer a very short reply. 4.75e+08. In the year 2008, what is the difference between the Aid flow (current US$) of Latin America(developing only) and Aid flow (current US$) of Ecuador?
Give a very brief answer. 4.72e+08. In the year 2008, what is the difference between the Aid flow (current US$) in Latin America(developing only) and Aid flow (current US$) in Iran?
Ensure brevity in your answer.  4.77e+08. In the year 2008, what is the difference between the Aid flow (current US$) in Botswana and Aid flow (current US$) in Ecuador?
Give a very brief answer. -3.08e+06. In the year 2008, what is the difference between the Aid flow (current US$) of Botswana and Aid flow (current US$) of Iran?
Make the answer very short. 1.21e+06. In the year 2008, what is the difference between the Aid flow (current US$) in Ecuador and Aid flow (current US$) in Iran?
Give a very brief answer. 4.29e+06. In the year 2009, what is the difference between the Aid flow (current US$) in Latin America(developing only) and Aid flow (current US$) in Botswana?
Give a very brief answer. 4.44e+08. In the year 2009, what is the difference between the Aid flow (current US$) in Latin America(developing only) and Aid flow (current US$) in Ecuador?
Provide a short and direct response. 4.42e+08. In the year 2009, what is the difference between the Aid flow (current US$) of Latin America(developing only) and Aid flow (current US$) of Iran?
Your answer should be very brief. 4.42e+08. In the year 2009, what is the difference between the Aid flow (current US$) of Botswana and Aid flow (current US$) of Ecuador?
Your response must be concise. -1.93e+06. What is the ratio of the Aid flow (current US$) of Latin America(developing only) in 1991 to that in 1995?
Your answer should be compact. 1.29. What is the ratio of the Aid flow (current US$) in Botswana in 1991 to that in 1995?
Make the answer very short. 2.39. What is the ratio of the Aid flow (current US$) of Ecuador in 1991 to that in 1995?
Keep it short and to the point. 1.1. What is the ratio of the Aid flow (current US$) in Iran in 1991 to that in 1995?
Provide a short and direct response. 6.93. What is the ratio of the Aid flow (current US$) in Latin America(developing only) in 1991 to that in 1997?
Provide a short and direct response. 1.1. What is the ratio of the Aid flow (current US$) in Botswana in 1991 to that in 1997?
Keep it short and to the point. 6.82. What is the ratio of the Aid flow (current US$) of Ecuador in 1991 to that in 1997?
Provide a succinct answer. 1.58. What is the ratio of the Aid flow (current US$) in Iran in 1991 to that in 1997?
Your response must be concise. 14.36. What is the ratio of the Aid flow (current US$) of Latin America(developing only) in 1991 to that in 2003?
Your answer should be compact. 0.98. What is the ratio of the Aid flow (current US$) of Botswana in 1991 to that in 2003?
Offer a terse response. 3.57. What is the ratio of the Aid flow (current US$) in Ecuador in 1991 to that in 2003?
Make the answer very short. 0.87. What is the ratio of the Aid flow (current US$) of Iran in 1991 to that in 2003?
Offer a terse response. 2.23. What is the ratio of the Aid flow (current US$) of Latin America(developing only) in 1991 to that in 2004?
Your answer should be compact. 0.82. What is the ratio of the Aid flow (current US$) of Botswana in 1991 to that in 2004?
Provide a short and direct response. 3.21. What is the ratio of the Aid flow (current US$) in Ecuador in 1991 to that in 2004?
Your answer should be very brief. 0.6. What is the ratio of the Aid flow (current US$) of Iran in 1991 to that in 2004?
Your answer should be compact. 4.67. What is the ratio of the Aid flow (current US$) in Latin America(developing only) in 1991 to that in 2007?
Provide a short and direct response. 0.38. What is the ratio of the Aid flow (current US$) of Botswana in 1991 to that in 2007?
Keep it short and to the point. 1.75. What is the ratio of the Aid flow (current US$) in Ecuador in 1991 to that in 2007?
Offer a terse response. 1.34. What is the ratio of the Aid flow (current US$) of Iran in 1991 to that in 2007?
Give a very brief answer. 40.2. What is the ratio of the Aid flow (current US$) of Latin America(developing only) in 1991 to that in 2008?
Your answer should be very brief. 0.35. What is the ratio of the Aid flow (current US$) of Botswana in 1991 to that in 2008?
Offer a very short reply. 2.78. What is the ratio of the Aid flow (current US$) of Ecuador in 1991 to that in 2008?
Give a very brief answer. 1.05. What is the ratio of the Aid flow (current US$) in Iran in 1991 to that in 2008?
Your response must be concise. 10.58. What is the ratio of the Aid flow (current US$) of Latin America(developing only) in 1991 to that in 2009?
Ensure brevity in your answer.  0.38. What is the ratio of the Aid flow (current US$) in Botswana in 1991 to that in 2009?
Offer a very short reply. 2.97. What is the ratio of the Aid flow (current US$) of Ecuador in 1991 to that in 2009?
Your response must be concise. 1.45. What is the ratio of the Aid flow (current US$) in Iran in 1991 to that in 2009?
Offer a very short reply. 0.61. What is the ratio of the Aid flow (current US$) of Latin America(developing only) in 1995 to that in 1997?
Your response must be concise. 0.85. What is the ratio of the Aid flow (current US$) of Botswana in 1995 to that in 1997?
Keep it short and to the point. 2.86. What is the ratio of the Aid flow (current US$) of Ecuador in 1995 to that in 1997?
Ensure brevity in your answer.  1.44. What is the ratio of the Aid flow (current US$) in Iran in 1995 to that in 1997?
Keep it short and to the point. 2.07. What is the ratio of the Aid flow (current US$) of Latin America(developing only) in 1995 to that in 2003?
Your answer should be very brief. 0.76. What is the ratio of the Aid flow (current US$) of Botswana in 1995 to that in 2003?
Your answer should be very brief. 1.5. What is the ratio of the Aid flow (current US$) in Ecuador in 1995 to that in 2003?
Your answer should be very brief. 0.8. What is the ratio of the Aid flow (current US$) of Iran in 1995 to that in 2003?
Offer a terse response. 0.32. What is the ratio of the Aid flow (current US$) of Latin America(developing only) in 1995 to that in 2004?
Make the answer very short. 0.63. What is the ratio of the Aid flow (current US$) of Botswana in 1995 to that in 2004?
Your answer should be compact. 1.35. What is the ratio of the Aid flow (current US$) of Ecuador in 1995 to that in 2004?
Give a very brief answer. 0.55. What is the ratio of the Aid flow (current US$) in Iran in 1995 to that in 2004?
Provide a succinct answer. 0.67. What is the ratio of the Aid flow (current US$) of Latin America(developing only) in 1995 to that in 2007?
Ensure brevity in your answer.  0.29. What is the ratio of the Aid flow (current US$) of Botswana in 1995 to that in 2007?
Provide a succinct answer. 0.73. What is the ratio of the Aid flow (current US$) in Ecuador in 1995 to that in 2007?
Provide a succinct answer. 1.22. What is the ratio of the Aid flow (current US$) in Latin America(developing only) in 1995 to that in 2008?
Your response must be concise. 0.27. What is the ratio of the Aid flow (current US$) in Botswana in 1995 to that in 2008?
Provide a short and direct response. 1.16. What is the ratio of the Aid flow (current US$) of Ecuador in 1995 to that in 2008?
Offer a very short reply. 0.95. What is the ratio of the Aid flow (current US$) in Iran in 1995 to that in 2008?
Provide a succinct answer. 1.53. What is the ratio of the Aid flow (current US$) of Latin America(developing only) in 1995 to that in 2009?
Offer a very short reply. 0.29. What is the ratio of the Aid flow (current US$) of Botswana in 1995 to that in 2009?
Your response must be concise. 1.24. What is the ratio of the Aid flow (current US$) in Ecuador in 1995 to that in 2009?
Your answer should be compact. 1.32. What is the ratio of the Aid flow (current US$) in Iran in 1995 to that in 2009?
Provide a succinct answer. 0.09. What is the ratio of the Aid flow (current US$) in Latin America(developing only) in 1997 to that in 2003?
Offer a very short reply. 0.89. What is the ratio of the Aid flow (current US$) in Botswana in 1997 to that in 2003?
Make the answer very short. 0.52. What is the ratio of the Aid flow (current US$) in Ecuador in 1997 to that in 2003?
Make the answer very short. 0.55. What is the ratio of the Aid flow (current US$) in Iran in 1997 to that in 2003?
Make the answer very short. 0.16. What is the ratio of the Aid flow (current US$) of Latin America(developing only) in 1997 to that in 2004?
Provide a short and direct response. 0.74. What is the ratio of the Aid flow (current US$) of Botswana in 1997 to that in 2004?
Your answer should be very brief. 0.47. What is the ratio of the Aid flow (current US$) of Ecuador in 1997 to that in 2004?
Your answer should be compact. 0.38. What is the ratio of the Aid flow (current US$) in Iran in 1997 to that in 2004?
Keep it short and to the point. 0.33. What is the ratio of the Aid flow (current US$) in Latin America(developing only) in 1997 to that in 2007?
Your answer should be compact. 0.34. What is the ratio of the Aid flow (current US$) of Botswana in 1997 to that in 2007?
Offer a very short reply. 0.26. What is the ratio of the Aid flow (current US$) in Ecuador in 1997 to that in 2007?
Keep it short and to the point. 0.85. What is the ratio of the Aid flow (current US$) in Latin America(developing only) in 1997 to that in 2008?
Make the answer very short. 0.32. What is the ratio of the Aid flow (current US$) in Botswana in 1997 to that in 2008?
Your response must be concise. 0.41. What is the ratio of the Aid flow (current US$) in Ecuador in 1997 to that in 2008?
Your answer should be compact. 0.66. What is the ratio of the Aid flow (current US$) of Iran in 1997 to that in 2008?
Keep it short and to the point. 0.74. What is the ratio of the Aid flow (current US$) in Latin America(developing only) in 1997 to that in 2009?
Your response must be concise. 0.34. What is the ratio of the Aid flow (current US$) in Botswana in 1997 to that in 2009?
Your response must be concise. 0.44. What is the ratio of the Aid flow (current US$) in Ecuador in 1997 to that in 2009?
Provide a short and direct response. 0.91. What is the ratio of the Aid flow (current US$) in Iran in 1997 to that in 2009?
Your answer should be very brief. 0.04. What is the ratio of the Aid flow (current US$) of Latin America(developing only) in 2003 to that in 2004?
Ensure brevity in your answer.  0.83. What is the ratio of the Aid flow (current US$) in Botswana in 2003 to that in 2004?
Provide a succinct answer. 0.9. What is the ratio of the Aid flow (current US$) in Ecuador in 2003 to that in 2004?
Offer a very short reply. 0.69. What is the ratio of the Aid flow (current US$) in Iran in 2003 to that in 2004?
Provide a short and direct response. 2.09. What is the ratio of the Aid flow (current US$) in Latin America(developing only) in 2003 to that in 2007?
Your answer should be compact. 0.39. What is the ratio of the Aid flow (current US$) in Botswana in 2003 to that in 2007?
Provide a short and direct response. 0.49. What is the ratio of the Aid flow (current US$) in Ecuador in 2003 to that in 2007?
Your response must be concise. 1.54. What is the ratio of the Aid flow (current US$) of Latin America(developing only) in 2003 to that in 2008?
Offer a very short reply. 0.36. What is the ratio of the Aid flow (current US$) of Botswana in 2003 to that in 2008?
Give a very brief answer. 0.78. What is the ratio of the Aid flow (current US$) of Ecuador in 2003 to that in 2008?
Keep it short and to the point. 1.2. What is the ratio of the Aid flow (current US$) of Iran in 2003 to that in 2008?
Your answer should be very brief. 4.74. What is the ratio of the Aid flow (current US$) of Latin America(developing only) in 2003 to that in 2009?
Your answer should be compact. 0.38. What is the ratio of the Aid flow (current US$) in Botswana in 2003 to that in 2009?
Ensure brevity in your answer.  0.83. What is the ratio of the Aid flow (current US$) in Ecuador in 2003 to that in 2009?
Provide a short and direct response. 1.66. What is the ratio of the Aid flow (current US$) of Iran in 2003 to that in 2009?
Offer a terse response. 0.27. What is the ratio of the Aid flow (current US$) in Latin America(developing only) in 2004 to that in 2007?
Keep it short and to the point. 0.47. What is the ratio of the Aid flow (current US$) in Botswana in 2004 to that in 2007?
Offer a very short reply. 0.55. What is the ratio of the Aid flow (current US$) in Ecuador in 2004 to that in 2007?
Provide a short and direct response. 2.22. What is the ratio of the Aid flow (current US$) in Iran in 2004 to that in 2007?
Make the answer very short. 8.6. What is the ratio of the Aid flow (current US$) in Latin America(developing only) in 2004 to that in 2008?
Keep it short and to the point. 0.43. What is the ratio of the Aid flow (current US$) in Botswana in 2004 to that in 2008?
Give a very brief answer. 0.86. What is the ratio of the Aid flow (current US$) in Ecuador in 2004 to that in 2008?
Your answer should be very brief. 1.73. What is the ratio of the Aid flow (current US$) in Iran in 2004 to that in 2008?
Give a very brief answer. 2.26. What is the ratio of the Aid flow (current US$) in Latin America(developing only) in 2004 to that in 2009?
Make the answer very short. 0.46. What is the ratio of the Aid flow (current US$) of Botswana in 2004 to that in 2009?
Ensure brevity in your answer.  0.92. What is the ratio of the Aid flow (current US$) of Ecuador in 2004 to that in 2009?
Offer a terse response. 2.4. What is the ratio of the Aid flow (current US$) of Iran in 2004 to that in 2009?
Give a very brief answer. 0.13. What is the ratio of the Aid flow (current US$) in Latin America(developing only) in 2007 to that in 2008?
Provide a succinct answer. 0.93. What is the ratio of the Aid flow (current US$) of Botswana in 2007 to that in 2008?
Provide a succinct answer. 1.59. What is the ratio of the Aid flow (current US$) in Ecuador in 2007 to that in 2008?
Give a very brief answer. 0.78. What is the ratio of the Aid flow (current US$) of Iran in 2007 to that in 2008?
Your answer should be compact. 0.26. What is the ratio of the Aid flow (current US$) in Latin America(developing only) in 2007 to that in 2009?
Offer a terse response. 0.99. What is the ratio of the Aid flow (current US$) in Botswana in 2007 to that in 2009?
Provide a short and direct response. 1.69. What is the ratio of the Aid flow (current US$) in Ecuador in 2007 to that in 2009?
Your answer should be compact. 1.08. What is the ratio of the Aid flow (current US$) of Iran in 2007 to that in 2009?
Provide a succinct answer. 0.02. What is the ratio of the Aid flow (current US$) in Latin America(developing only) in 2008 to that in 2009?
Provide a short and direct response. 1.07. What is the ratio of the Aid flow (current US$) of Botswana in 2008 to that in 2009?
Your answer should be very brief. 1.07. What is the ratio of the Aid flow (current US$) of Ecuador in 2008 to that in 2009?
Provide a short and direct response. 1.38. What is the ratio of the Aid flow (current US$) of Iran in 2008 to that in 2009?
Your answer should be compact. 0.06. What is the difference between the highest and the second highest Aid flow (current US$) of Latin America(developing only)?
Your answer should be compact. 3.19e+07. What is the difference between the highest and the second highest Aid flow (current US$) in Botswana?
Provide a succinct answer. 1.67e+06. What is the difference between the highest and the second highest Aid flow (current US$) of Ecuador?
Offer a terse response. 2.39e+06. What is the difference between the highest and the second highest Aid flow (current US$) of Iran?
Provide a short and direct response. 1.30e+06. What is the difference between the highest and the lowest Aid flow (current US$) of Latin America(developing only)?
Offer a very short reply. 3.47e+08. What is the difference between the highest and the lowest Aid flow (current US$) in Botswana?
Your answer should be compact. 3.32e+06. What is the difference between the highest and the lowest Aid flow (current US$) in Ecuador?
Ensure brevity in your answer.  4.80e+06. What is the difference between the highest and the lowest Aid flow (current US$) in Iran?
Give a very brief answer. 3.26e+06. 